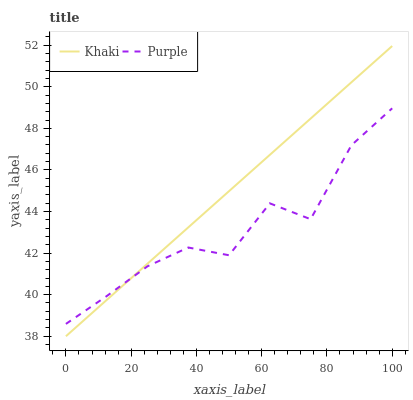Does Purple have the minimum area under the curve?
Answer yes or no. Yes. Does Khaki have the maximum area under the curve?
Answer yes or no. Yes. Does Khaki have the minimum area under the curve?
Answer yes or no. No. Is Khaki the smoothest?
Answer yes or no. Yes. Is Purple the roughest?
Answer yes or no. Yes. Is Khaki the roughest?
Answer yes or no. No. Does Khaki have the lowest value?
Answer yes or no. Yes. Does Khaki have the highest value?
Answer yes or no. Yes. Does Khaki intersect Purple?
Answer yes or no. Yes. Is Khaki less than Purple?
Answer yes or no. No. Is Khaki greater than Purple?
Answer yes or no. No. 